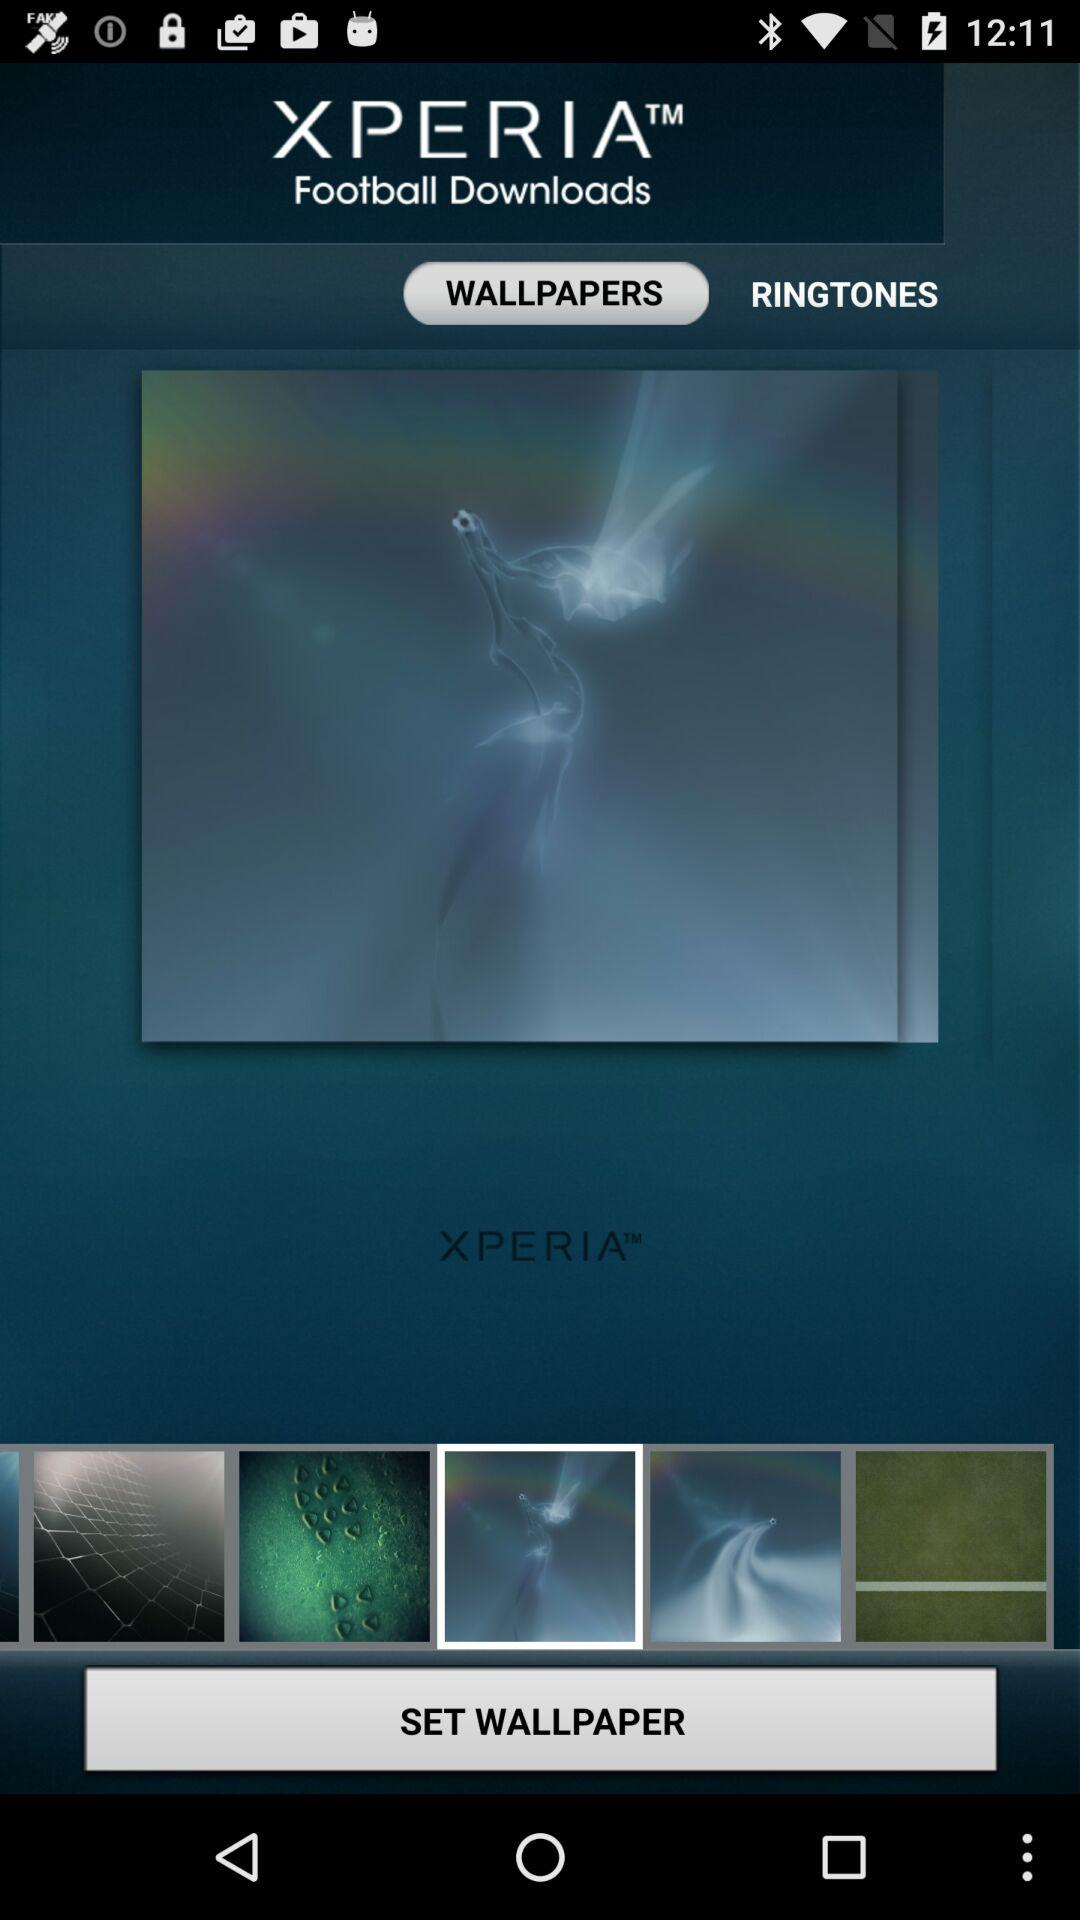What is the name of the application? The name of the application is "XPERIA™ Football Downloads". 